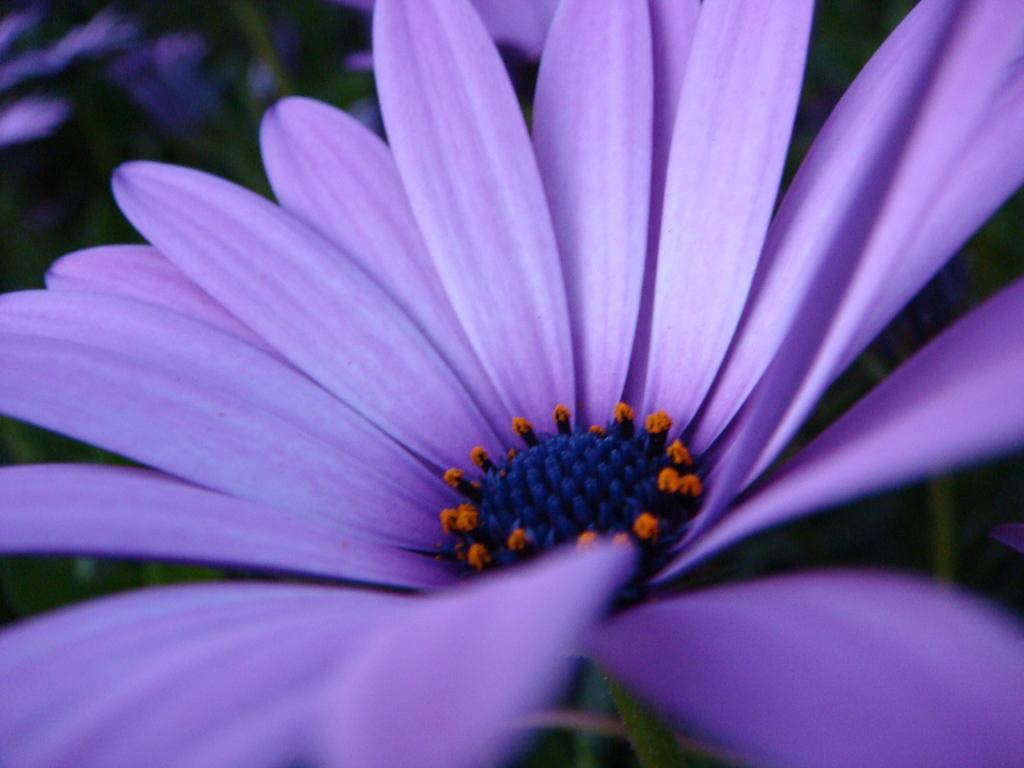Can you describe this image briefly? In this picture there is a flower in the center of the image and there are other flowers in the background area of the image. 